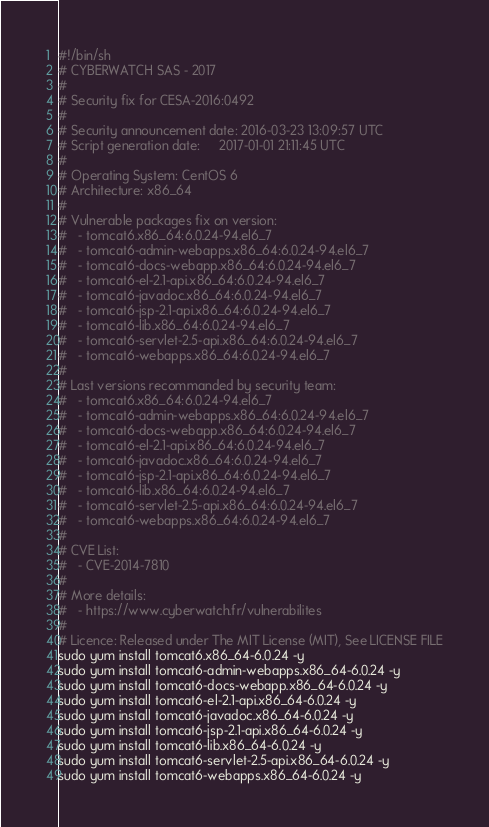Convert code to text. <code><loc_0><loc_0><loc_500><loc_500><_Bash_>#!/bin/sh
# CYBERWATCH SAS - 2017
#
# Security fix for CESA-2016:0492
#
# Security announcement date: 2016-03-23 13:09:57 UTC
# Script generation date:     2017-01-01 21:11:45 UTC
#
# Operating System: CentOS 6
# Architecture: x86_64
#
# Vulnerable packages fix on version:
#   - tomcat6.x86_64:6.0.24-94.el6_7
#   - tomcat6-admin-webapps.x86_64:6.0.24-94.el6_7
#   - tomcat6-docs-webapp.x86_64:6.0.24-94.el6_7
#   - tomcat6-el-2.1-api.x86_64:6.0.24-94.el6_7
#   - tomcat6-javadoc.x86_64:6.0.24-94.el6_7
#   - tomcat6-jsp-2.1-api.x86_64:6.0.24-94.el6_7
#   - tomcat6-lib.x86_64:6.0.24-94.el6_7
#   - tomcat6-servlet-2.5-api.x86_64:6.0.24-94.el6_7
#   - tomcat6-webapps.x86_64:6.0.24-94.el6_7
#
# Last versions recommanded by security team:
#   - tomcat6.x86_64:6.0.24-94.el6_7
#   - tomcat6-admin-webapps.x86_64:6.0.24-94.el6_7
#   - tomcat6-docs-webapp.x86_64:6.0.24-94.el6_7
#   - tomcat6-el-2.1-api.x86_64:6.0.24-94.el6_7
#   - tomcat6-javadoc.x86_64:6.0.24-94.el6_7
#   - tomcat6-jsp-2.1-api.x86_64:6.0.24-94.el6_7
#   - tomcat6-lib.x86_64:6.0.24-94.el6_7
#   - tomcat6-servlet-2.5-api.x86_64:6.0.24-94.el6_7
#   - tomcat6-webapps.x86_64:6.0.24-94.el6_7
#
# CVE List:
#   - CVE-2014-7810
#
# More details:
#   - https://www.cyberwatch.fr/vulnerabilites
#
# Licence: Released under The MIT License (MIT), See LICENSE FILE
sudo yum install tomcat6.x86_64-6.0.24 -y 
sudo yum install tomcat6-admin-webapps.x86_64-6.0.24 -y 
sudo yum install tomcat6-docs-webapp.x86_64-6.0.24 -y 
sudo yum install tomcat6-el-2.1-api.x86_64-6.0.24 -y 
sudo yum install tomcat6-javadoc.x86_64-6.0.24 -y 
sudo yum install tomcat6-jsp-2.1-api.x86_64-6.0.24 -y 
sudo yum install tomcat6-lib.x86_64-6.0.24 -y 
sudo yum install tomcat6-servlet-2.5-api.x86_64-6.0.24 -y 
sudo yum install tomcat6-webapps.x86_64-6.0.24 -y 
</code> 